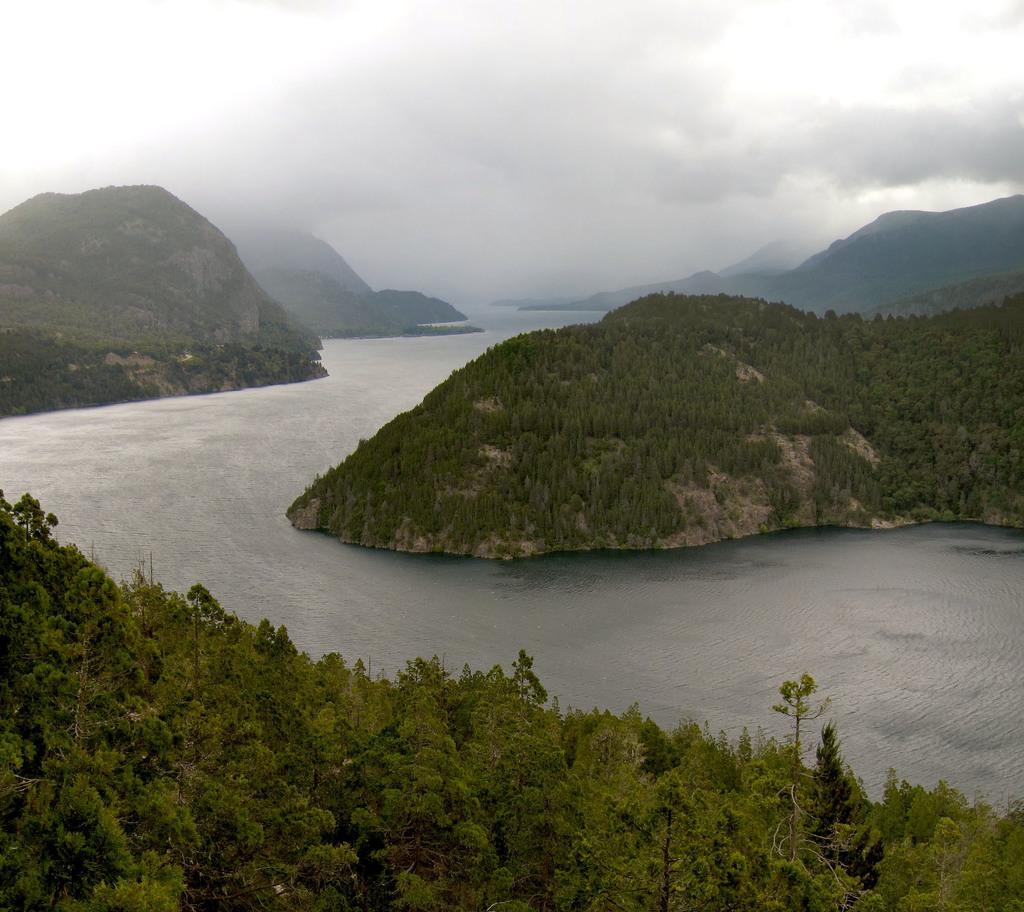Can you describe this image briefly? In this picture there are mountains and there are trees on the mountains. In the foreground there are trees. At the top there are clouds. At the bottom there is water. 